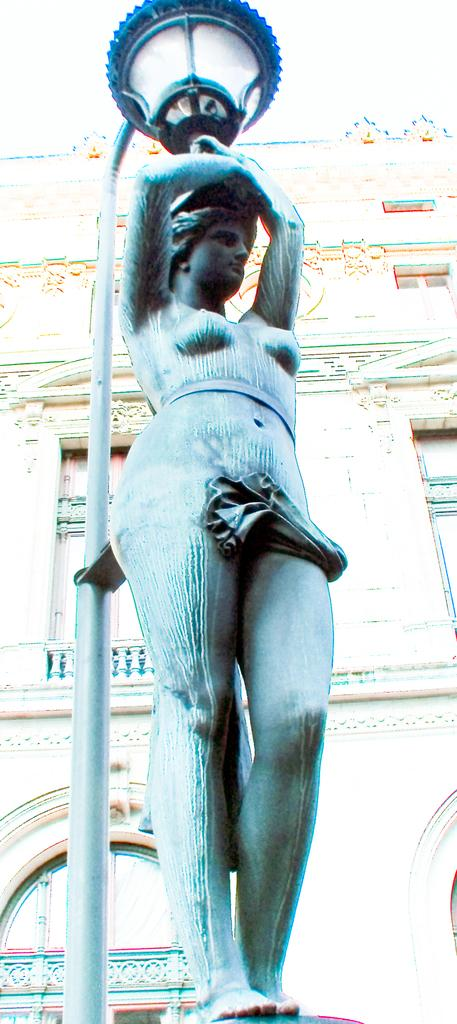What is the main subject of the image? There is a statue in the image. What is on top of the statue? The statue has a light on top of it. What can be seen in the background of the image? There is a pole and a building with windows in the background of the image. Can you see any rabbits swimming in the lake in the image? There is no lake or rabbits present in the image; it features a statue with a light on top and a background with a pole and a building with windows. 